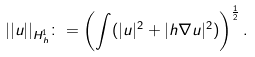Convert formula to latex. <formula><loc_0><loc_0><loc_500><loc_500>| | u | | _ { H ^ { 1 } _ { h } } \colon = \left ( \int ( | u | ^ { 2 } + | h \nabla u | ^ { 2 } ) \right ) ^ { \frac { 1 } { 2 } } .</formula> 